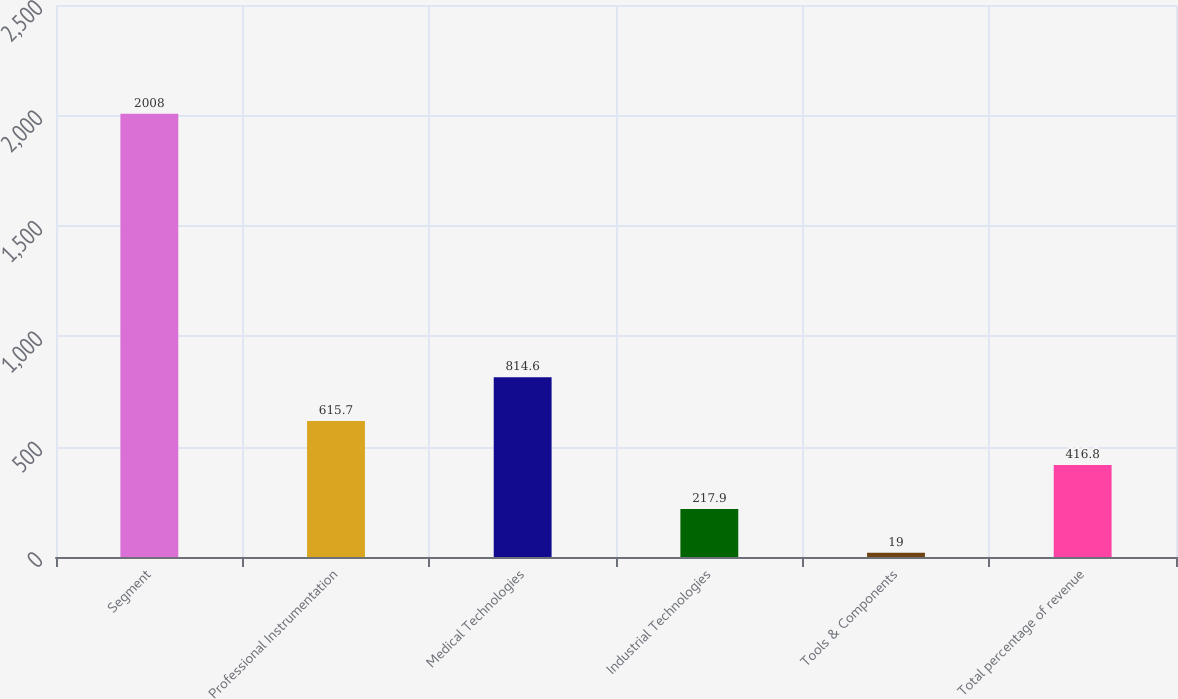Convert chart. <chart><loc_0><loc_0><loc_500><loc_500><bar_chart><fcel>Segment<fcel>Professional Instrumentation<fcel>Medical Technologies<fcel>Industrial Technologies<fcel>Tools & Components<fcel>Total percentage of revenue<nl><fcel>2008<fcel>615.7<fcel>814.6<fcel>217.9<fcel>19<fcel>416.8<nl></chart> 